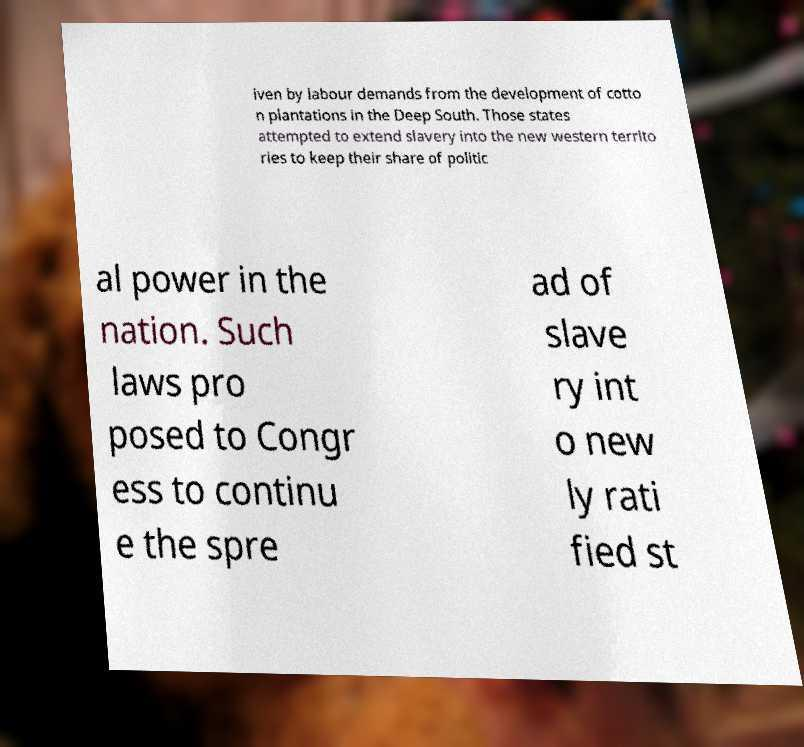I need the written content from this picture converted into text. Can you do that? iven by labour demands from the development of cotto n plantations in the Deep South. Those states attempted to extend slavery into the new western territo ries to keep their share of politic al power in the nation. Such laws pro posed to Congr ess to continu e the spre ad of slave ry int o new ly rati fied st 